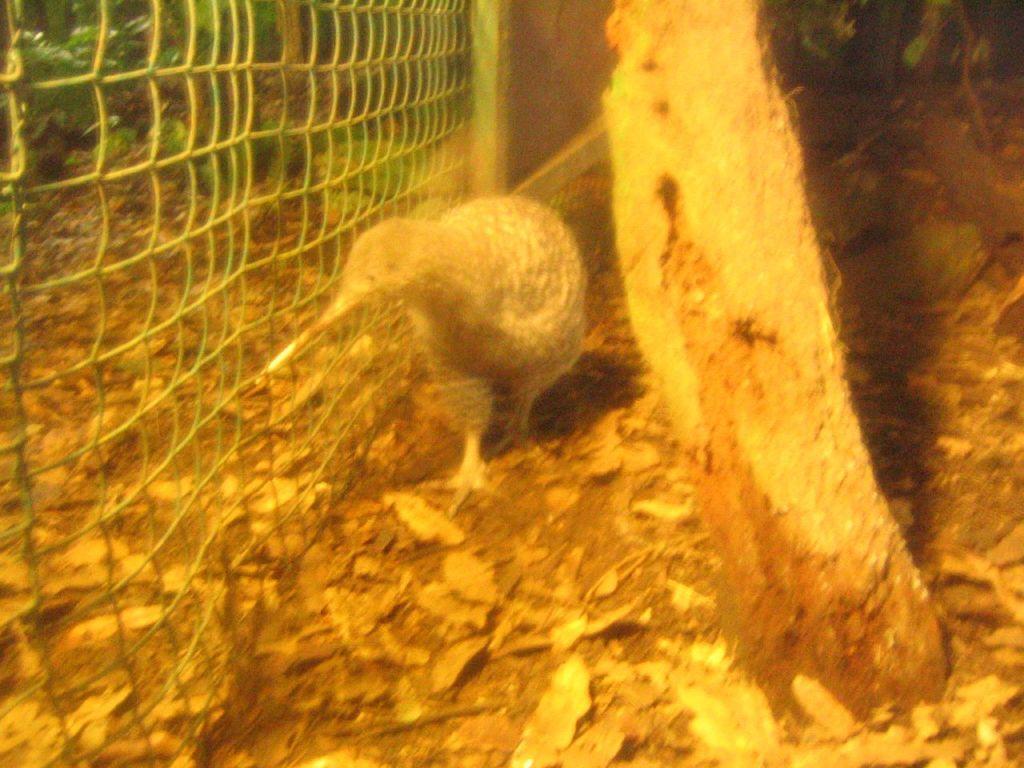Could you give a brief overview of what you see in this image? In this image there is a bird beside the fence, there are plants, few leaves on the ground and the trunk of the tree. 